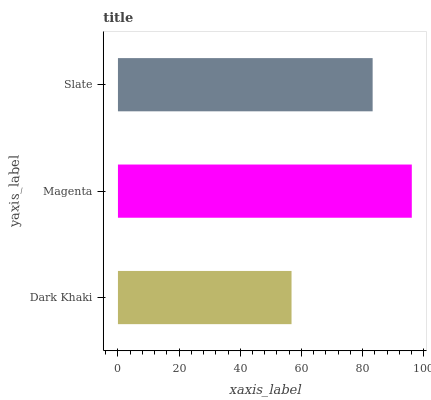Is Dark Khaki the minimum?
Answer yes or no. Yes. Is Magenta the maximum?
Answer yes or no. Yes. Is Slate the minimum?
Answer yes or no. No. Is Slate the maximum?
Answer yes or no. No. Is Magenta greater than Slate?
Answer yes or no. Yes. Is Slate less than Magenta?
Answer yes or no. Yes. Is Slate greater than Magenta?
Answer yes or no. No. Is Magenta less than Slate?
Answer yes or no. No. Is Slate the high median?
Answer yes or no. Yes. Is Slate the low median?
Answer yes or no. Yes. Is Magenta the high median?
Answer yes or no. No. Is Dark Khaki the low median?
Answer yes or no. No. 